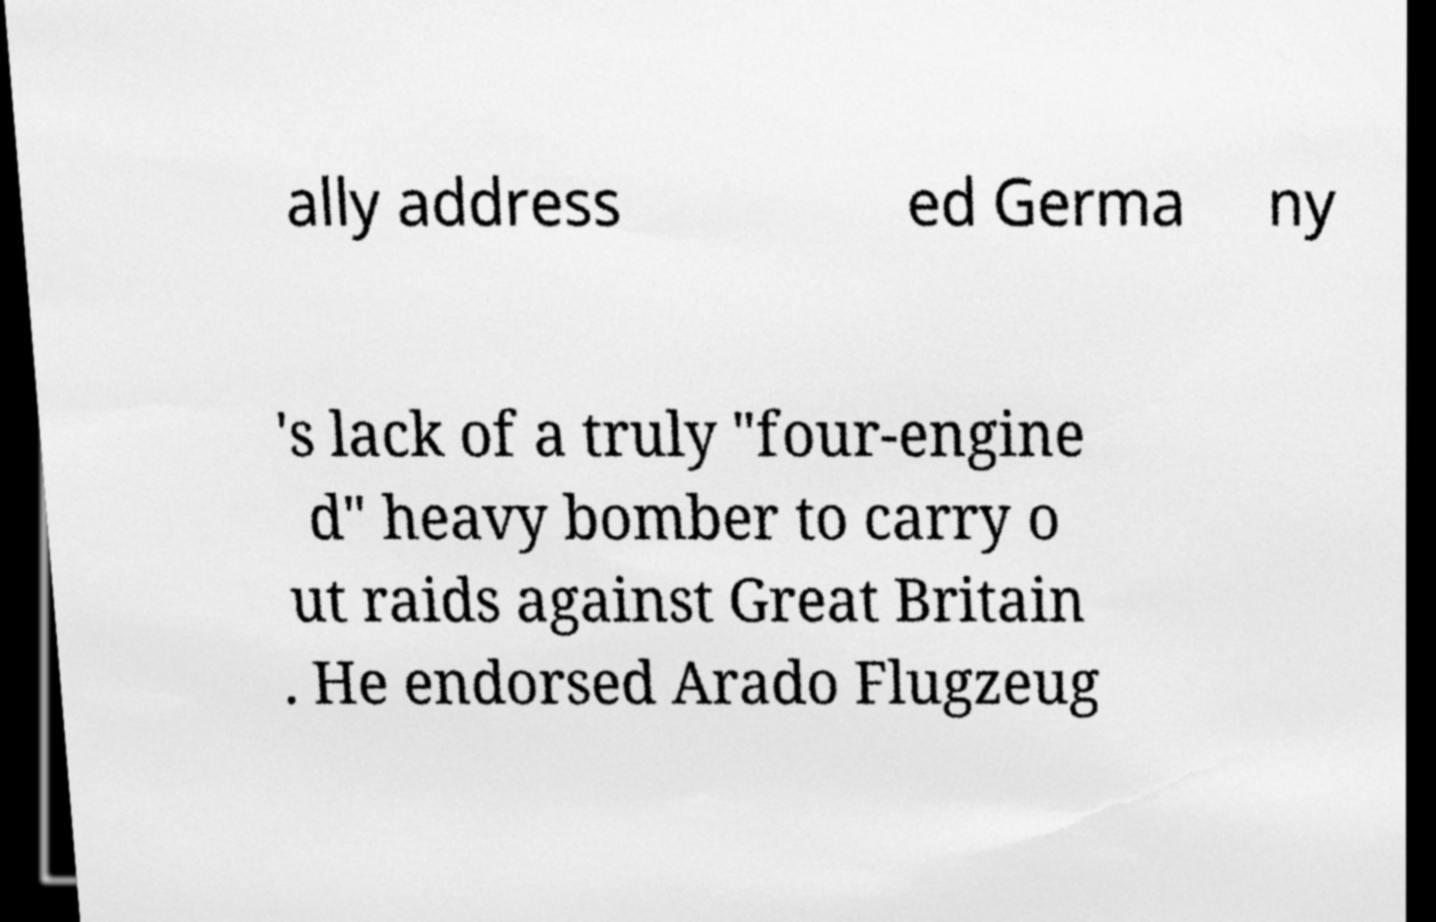Could you assist in decoding the text presented in this image and type it out clearly? ally address ed Germa ny 's lack of a truly "four-engine d" heavy bomber to carry o ut raids against Great Britain . He endorsed Arado Flugzeug 